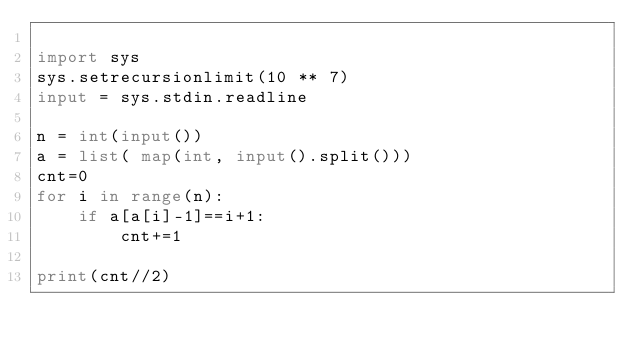Convert code to text. <code><loc_0><loc_0><loc_500><loc_500><_Python_>
import sys
sys.setrecursionlimit(10 ** 7)
input = sys.stdin.readline

n = int(input())
a = list( map(int, input().split()))
cnt=0
for i in range(n):
    if a[a[i]-1]==i+1:
        cnt+=1

print(cnt//2)</code> 